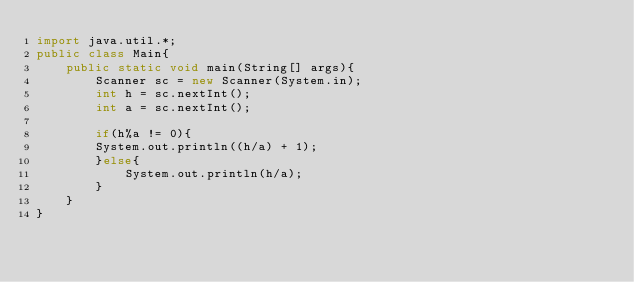Convert code to text. <code><loc_0><loc_0><loc_500><loc_500><_Java_>import java.util.*;
public class Main{
    public static void main(String[] args){
        Scanner sc = new Scanner(System.in);
        int h = sc.nextInt();
        int a = sc.nextInt();

        if(h%a != 0){
        System.out.println((h/a) + 1);
        }else{
            System.out.println(h/a);
        }
    }
}</code> 